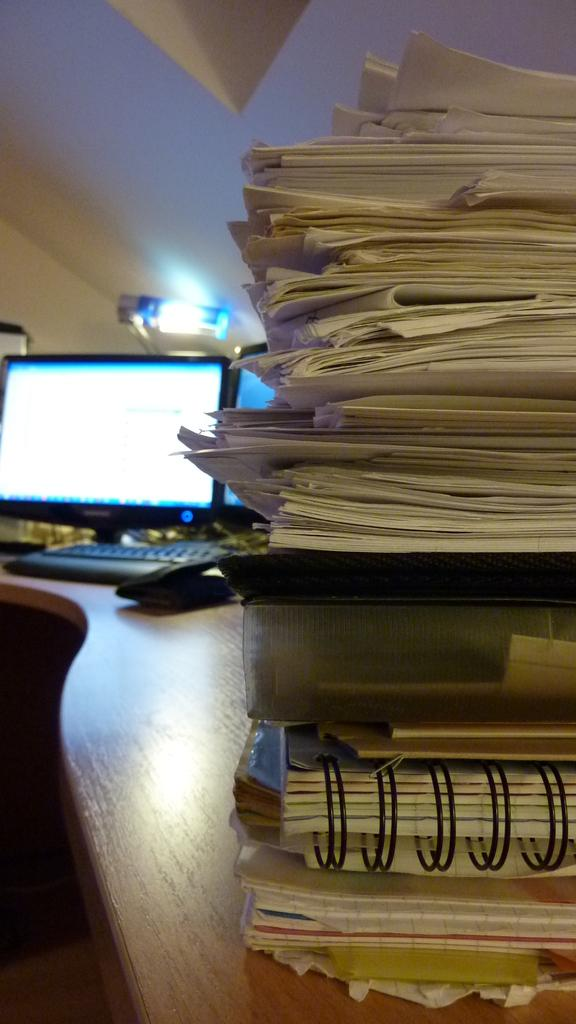What objects are on the table in the image? There are papers and files on a table in the image. What electronic device is present in the image? There is a monitor in the image. What is used for typing in the image? There is a keyboard in the image. What personal item can be seen in the image? There is a wallet in the image. What source of light is visible in the image? There is a light at the top of the image. What type of waves can be seen in the image? There are no waves present in the image. 